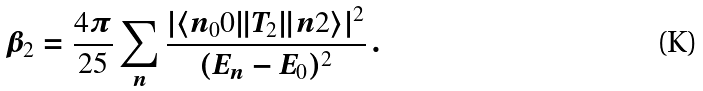<formula> <loc_0><loc_0><loc_500><loc_500>\beta _ { 2 } = \frac { 4 \pi } { 2 5 } \sum _ { n } \frac { | \langle n _ { 0 } 0 \| T _ { 2 } \| n 2 \rangle | ^ { 2 } } { ( E _ { n } - E _ { 0 } ) ^ { 2 } } \, .</formula> 